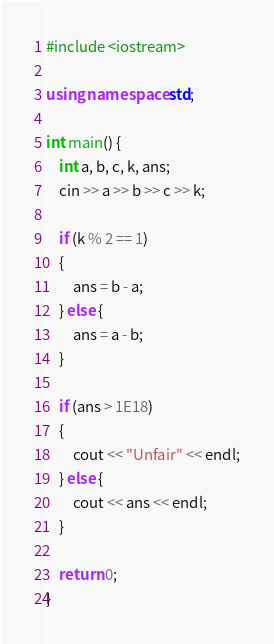<code> <loc_0><loc_0><loc_500><loc_500><_C++_>#include <iostream>

using namespace std;

int main() {
	int a, b, c, k, ans;
	cin >> a >> b >> c >> k;

	if (k % 2 == 1)
	{
		ans = b - a;
	} else {
		ans = a - b;
	}

	if (ans > 1E18)
	{
		cout << "Unfair" << endl;
	} else {
		cout << ans << endl;
	}

	return 0;
}</code> 